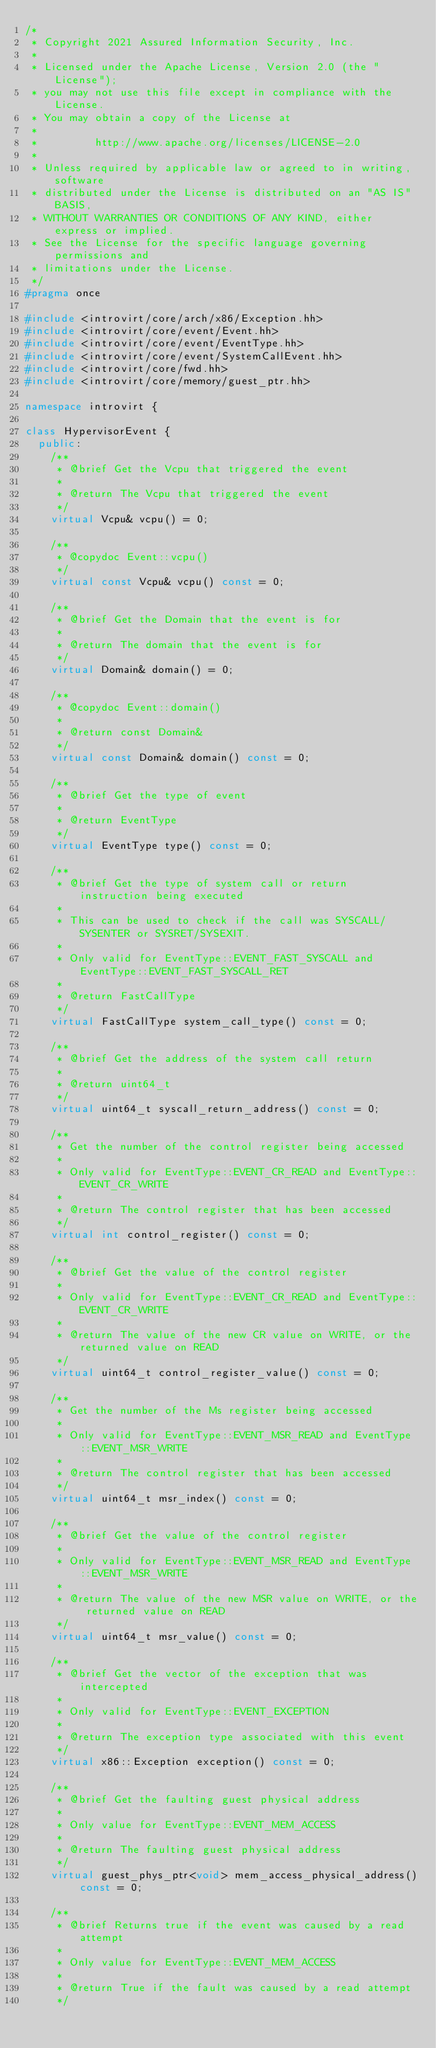<code> <loc_0><loc_0><loc_500><loc_500><_C++_>/*
 * Copyright 2021 Assured Information Security, Inc.
 *
 * Licensed under the Apache License, Version 2.0 (the "License");
 * you may not use this file except in compliance with the License.
 * You may obtain a copy of the License at
 *
 *         http://www.apache.org/licenses/LICENSE-2.0
 *
 * Unless required by applicable law or agreed to in writing, software
 * distributed under the License is distributed on an "AS IS" BASIS,
 * WITHOUT WARRANTIES OR CONDITIONS OF ANY KIND, either express or implied.
 * See the License for the specific language governing permissions and
 * limitations under the License.
 */
#pragma once

#include <introvirt/core/arch/x86/Exception.hh>
#include <introvirt/core/event/Event.hh>
#include <introvirt/core/event/EventType.hh>
#include <introvirt/core/event/SystemCallEvent.hh>
#include <introvirt/core/fwd.hh>
#include <introvirt/core/memory/guest_ptr.hh>

namespace introvirt {

class HypervisorEvent {
  public:
    /**
     * @brief Get the Vcpu that triggered the event
     *
     * @return The Vcpu that triggered the event
     */
    virtual Vcpu& vcpu() = 0;

    /**
     * @copydoc Event::vcpu()
     */
    virtual const Vcpu& vcpu() const = 0;

    /**
     * @brief Get the Domain that the event is for
     *
     * @return The domain that the event is for
     */
    virtual Domain& domain() = 0;

    /**
     * @copydoc Event::domain()
     *
     * @return const Domain&
     */
    virtual const Domain& domain() const = 0;

    /**
     * @brief Get the type of event
     *
     * @return EventType
     */
    virtual EventType type() const = 0;

    /**
     * @brief Get the type of system call or return instruction being executed
     *
     * This can be used to check if the call was SYSCALL/SYSENTER or SYSRET/SYSEXIT.
     *
     * Only valid for EventType::EVENT_FAST_SYSCALL and EventType::EVENT_FAST_SYSCALL_RET
     *
     * @return FastCallType
     */
    virtual FastCallType system_call_type() const = 0;

    /**
     * @brief Get the address of the system call return
     *
     * @return uint64_t
     */
    virtual uint64_t syscall_return_address() const = 0;

    /**
     * Get the number of the control register being accessed
     *
     * Only valid for EventType::EVENT_CR_READ and EventType::EVENT_CR_WRITE
     *
     * @return The control register that has been accessed
     */
    virtual int control_register() const = 0;

    /**
     * @brief Get the value of the control register
     *
     * Only valid for EventType::EVENT_CR_READ and EventType::EVENT_CR_WRITE
     *
     * @return The value of the new CR value on WRITE, or the returned value on READ
     */
    virtual uint64_t control_register_value() const = 0;

    /**
     * Get the number of the Ms register being accessed
     *
     * Only valid for EventType::EVENT_MSR_READ and EventType::EVENT_MSR_WRITE
     *
     * @return The control register that has been accessed
     */
    virtual uint64_t msr_index() const = 0;

    /**
     * @brief Get the value of the control register
     *
     * Only valid for EventType::EVENT_MSR_READ and EventType::EVENT_MSR_WRITE
     *
     * @return The value of the new MSR value on WRITE, or the returned value on READ
     */
    virtual uint64_t msr_value() const = 0;

    /**
     * @brief Get the vector of the exception that was intercepted
     *
     * Only valid for EventType::EVENT_EXCEPTION
     *
     * @return The exception type associated with this event
     */
    virtual x86::Exception exception() const = 0;

    /**
     * @brief Get the faulting guest physical address
     *
     * Only value for EventType::EVENT_MEM_ACCESS
     *
     * @return The faulting guest physical address
     */
    virtual guest_phys_ptr<void> mem_access_physical_address() const = 0;

    /**
     * @brief Returns true if the event was caused by a read attempt
     *
     * Only value for EventType::EVENT_MEM_ACCESS
     *
     * @return True if the fault was caused by a read attempt
     */</code> 